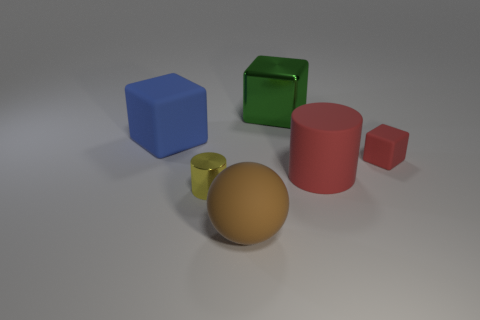Are there the same number of large shiny cubes left of the yellow shiny cylinder and large blue things?
Your answer should be compact. No. What number of other objects are the same shape as the big green object?
Provide a short and direct response. 2. The green metal object is what shape?
Your response must be concise. Cube. Is the material of the big green thing the same as the big blue cube?
Give a very brief answer. No. Are there the same number of red objects that are left of the matte ball and large things in front of the tiny matte thing?
Your response must be concise. No. Are there any large matte cylinders to the right of the big block that is to the right of the object that is on the left side of the yellow object?
Ensure brevity in your answer.  Yes. Is the red matte cylinder the same size as the shiny block?
Offer a very short reply. Yes. What is the color of the metallic object in front of the thing behind the big block left of the brown object?
Your answer should be very brief. Yellow. How many rubber things have the same color as the small matte block?
Offer a very short reply. 1. What number of large things are either yellow shiny things or yellow balls?
Offer a terse response. 0. 